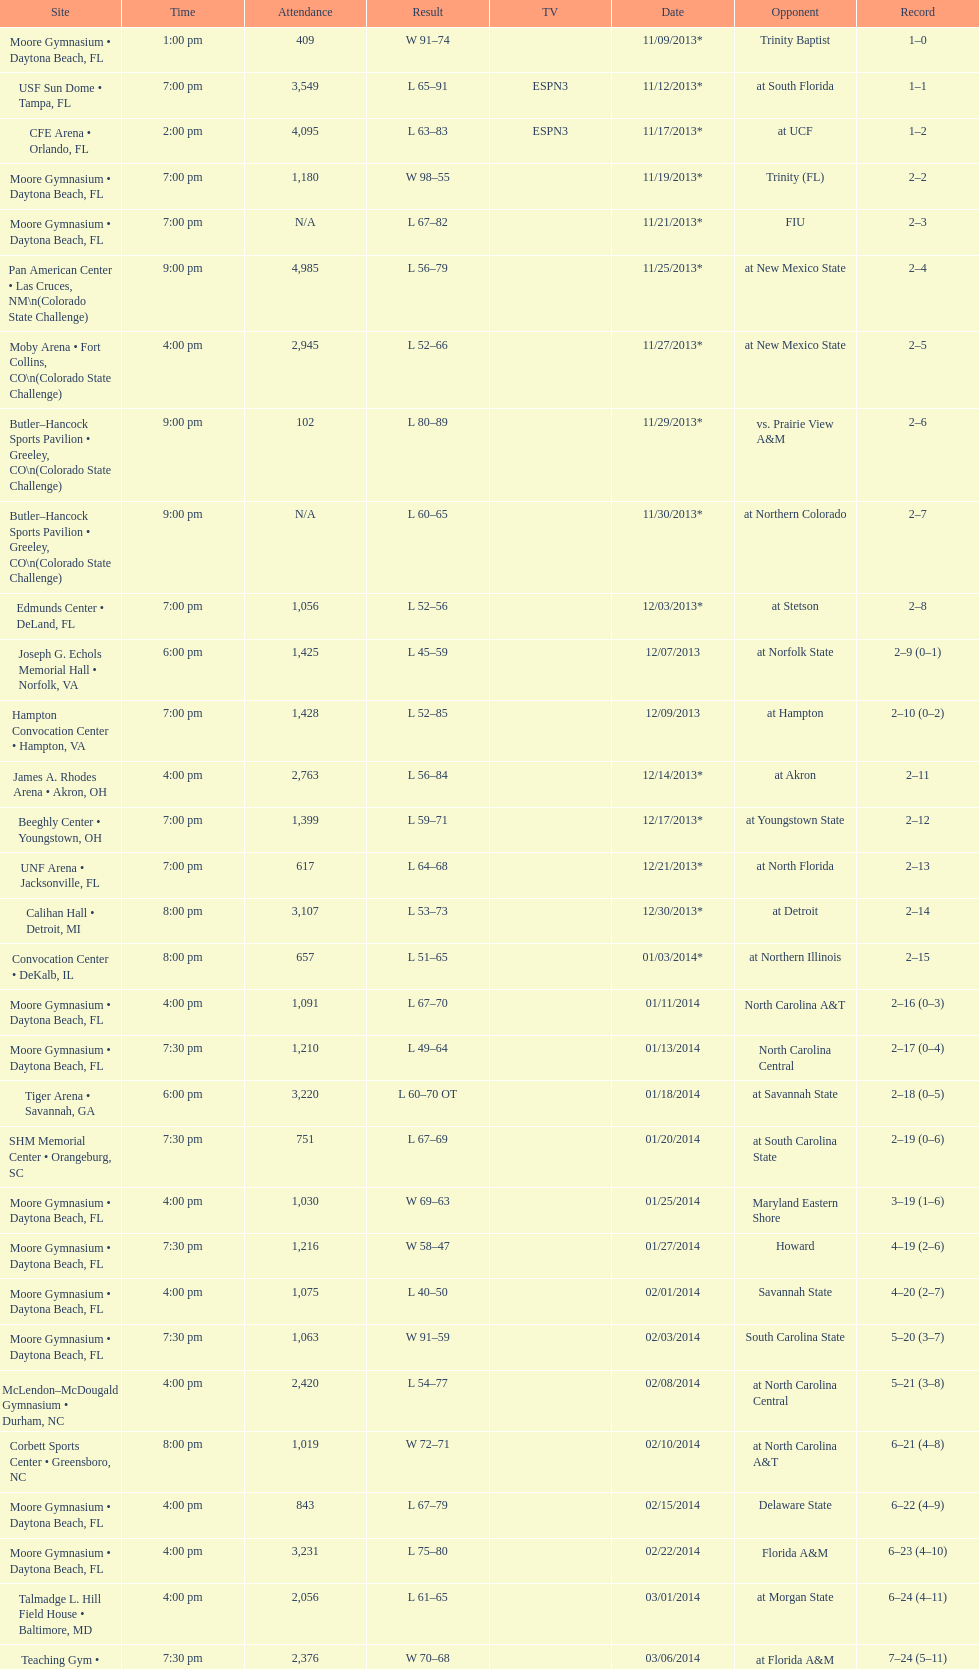How many teams had at most an attendance of 1,000? 6. 